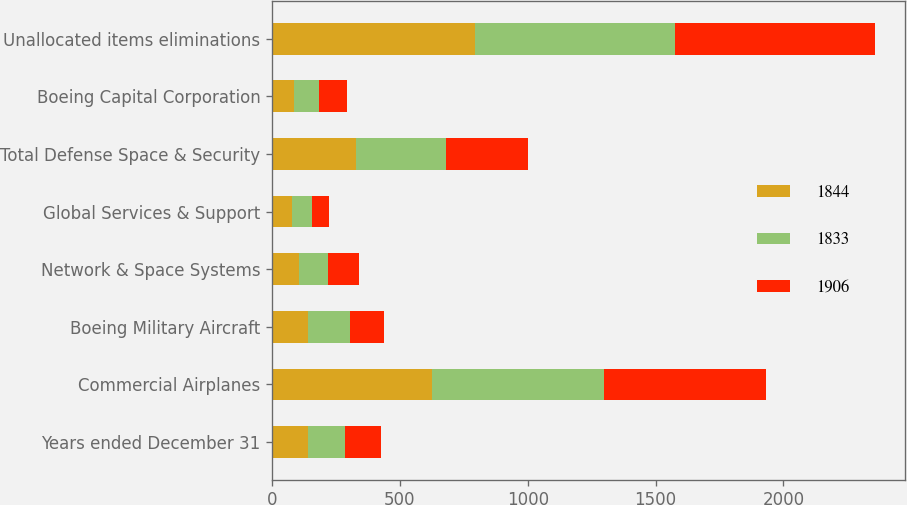Convert chart. <chart><loc_0><loc_0><loc_500><loc_500><stacked_bar_chart><ecel><fcel>Years ended December 31<fcel>Commercial Airplanes<fcel>Boeing Military Aircraft<fcel>Network & Space Systems<fcel>Global Services & Support<fcel>Total Defense Space & Security<fcel>Boeing Capital Corporation<fcel>Unallocated items eliminations<nl><fcel>1844<fcel>142<fcel>625<fcel>142<fcel>106<fcel>80<fcel>328<fcel>87<fcel>793<nl><fcel>1833<fcel>142<fcel>674<fcel>164<fcel>114<fcel>75<fcel>353<fcel>97<fcel>782<nl><fcel>1906<fcel>142<fcel>632<fcel>131<fcel>120<fcel>69<fcel>320<fcel>110<fcel>782<nl></chart> 